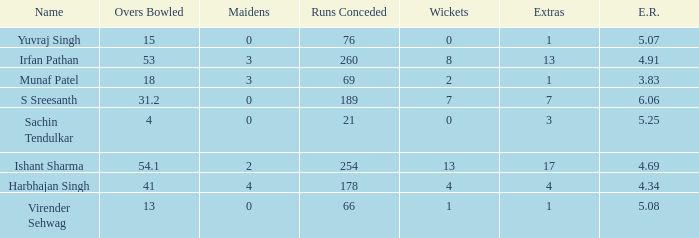Name the name for when overs bowled is 31.2 S Sreesanth. 